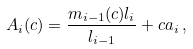<formula> <loc_0><loc_0><loc_500><loc_500>A _ { i } ( c ) = \frac { m _ { i - 1 } ( c ) l _ { i } } { l _ { i - 1 } } + c a _ { i } \, ,</formula> 